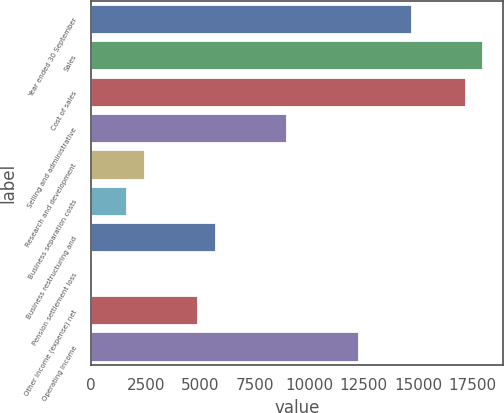<chart> <loc_0><loc_0><loc_500><loc_500><bar_chart><fcel>Year ended 30 September<fcel>Sales<fcel>Cost of sales<fcel>Selling and administrative<fcel>Research and development<fcel>Business separation costs<fcel>Business restructuring and<fcel>Pension settlement loss<fcel>Other income (expense) net<fcel>Operating Income<nl><fcel>14729.3<fcel>18000.1<fcel>17182.4<fcel>9005.31<fcel>2463.63<fcel>1645.92<fcel>5734.47<fcel>10.5<fcel>4916.76<fcel>12276.1<nl></chart> 